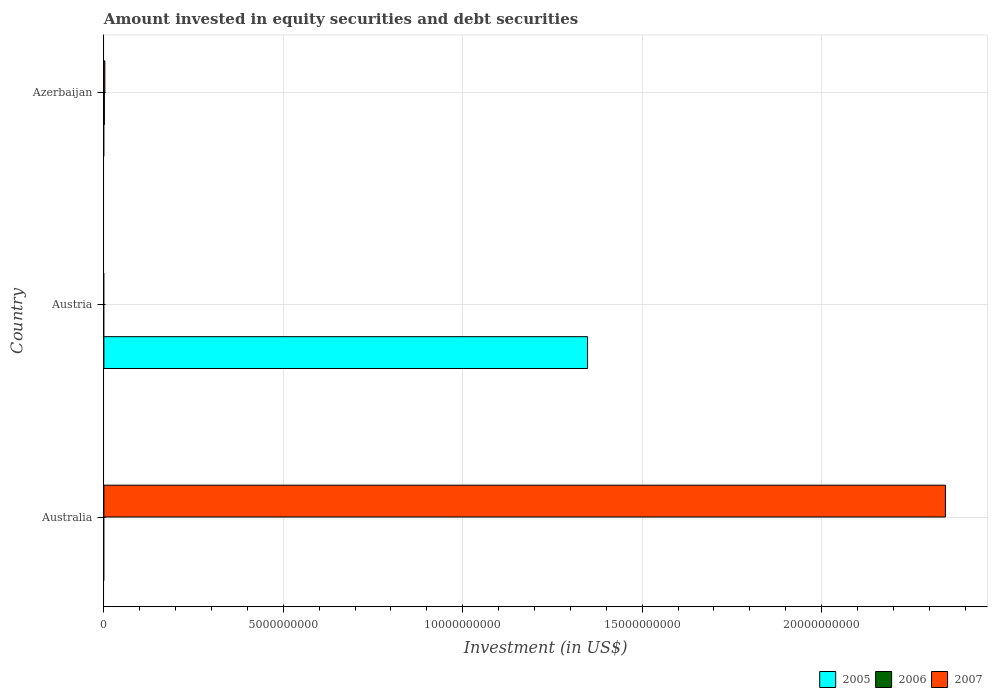Are the number of bars per tick equal to the number of legend labels?
Ensure brevity in your answer.  No. How many bars are there on the 3rd tick from the top?
Offer a very short reply. 1. How many bars are there on the 2nd tick from the bottom?
Ensure brevity in your answer.  1. What is the amount invested in equity securities and debt securities in 2005 in Austria?
Your response must be concise. 1.35e+1. Across all countries, what is the maximum amount invested in equity securities and debt securities in 2007?
Your answer should be compact. 2.35e+1. In which country was the amount invested in equity securities and debt securities in 2006 maximum?
Offer a very short reply. Azerbaijan. What is the total amount invested in equity securities and debt securities in 2005 in the graph?
Your answer should be compact. 1.35e+1. What is the difference between the amount invested in equity securities and debt securities in 2007 in Australia and that in Azerbaijan?
Ensure brevity in your answer.  2.34e+1. What is the average amount invested in equity securities and debt securities in 2005 per country?
Keep it short and to the point. 4.49e+09. What is the difference between the highest and the lowest amount invested in equity securities and debt securities in 2007?
Your response must be concise. 2.35e+1. How many bars are there?
Provide a short and direct response. 4. Are all the bars in the graph horizontal?
Offer a very short reply. Yes. Does the graph contain any zero values?
Your response must be concise. Yes. Where does the legend appear in the graph?
Your answer should be very brief. Bottom right. How many legend labels are there?
Make the answer very short. 3. What is the title of the graph?
Keep it short and to the point. Amount invested in equity securities and debt securities. What is the label or title of the X-axis?
Your answer should be compact. Investment (in US$). What is the label or title of the Y-axis?
Provide a succinct answer. Country. What is the Investment (in US$) in 2005 in Australia?
Provide a succinct answer. 0. What is the Investment (in US$) of 2007 in Australia?
Give a very brief answer. 2.35e+1. What is the Investment (in US$) of 2005 in Austria?
Keep it short and to the point. 1.35e+1. What is the Investment (in US$) of 2006 in Austria?
Your response must be concise. 0. What is the Investment (in US$) in 2007 in Austria?
Offer a terse response. 0. What is the Investment (in US$) in 2005 in Azerbaijan?
Give a very brief answer. 0. What is the Investment (in US$) in 2006 in Azerbaijan?
Make the answer very short. 1.20e+07. What is the Investment (in US$) in 2007 in Azerbaijan?
Ensure brevity in your answer.  2.64e+07. Across all countries, what is the maximum Investment (in US$) in 2005?
Your answer should be compact. 1.35e+1. Across all countries, what is the maximum Investment (in US$) in 2006?
Your answer should be very brief. 1.20e+07. Across all countries, what is the maximum Investment (in US$) of 2007?
Offer a very short reply. 2.35e+1. Across all countries, what is the minimum Investment (in US$) in 2005?
Give a very brief answer. 0. Across all countries, what is the minimum Investment (in US$) of 2006?
Make the answer very short. 0. What is the total Investment (in US$) in 2005 in the graph?
Your answer should be very brief. 1.35e+1. What is the total Investment (in US$) in 2006 in the graph?
Keep it short and to the point. 1.20e+07. What is the total Investment (in US$) of 2007 in the graph?
Your answer should be compact. 2.35e+1. What is the difference between the Investment (in US$) in 2007 in Australia and that in Azerbaijan?
Offer a terse response. 2.34e+1. What is the difference between the Investment (in US$) of 2005 in Austria and the Investment (in US$) of 2006 in Azerbaijan?
Offer a very short reply. 1.35e+1. What is the difference between the Investment (in US$) in 2005 in Austria and the Investment (in US$) in 2007 in Azerbaijan?
Provide a short and direct response. 1.35e+1. What is the average Investment (in US$) in 2005 per country?
Your answer should be compact. 4.49e+09. What is the average Investment (in US$) of 2006 per country?
Offer a terse response. 4.02e+06. What is the average Investment (in US$) in 2007 per country?
Keep it short and to the point. 7.83e+09. What is the difference between the Investment (in US$) of 2006 and Investment (in US$) of 2007 in Azerbaijan?
Your answer should be compact. -1.44e+07. What is the ratio of the Investment (in US$) in 2007 in Australia to that in Azerbaijan?
Your answer should be very brief. 887.47. What is the difference between the highest and the lowest Investment (in US$) in 2005?
Give a very brief answer. 1.35e+1. What is the difference between the highest and the lowest Investment (in US$) in 2006?
Offer a very short reply. 1.20e+07. What is the difference between the highest and the lowest Investment (in US$) of 2007?
Offer a terse response. 2.35e+1. 